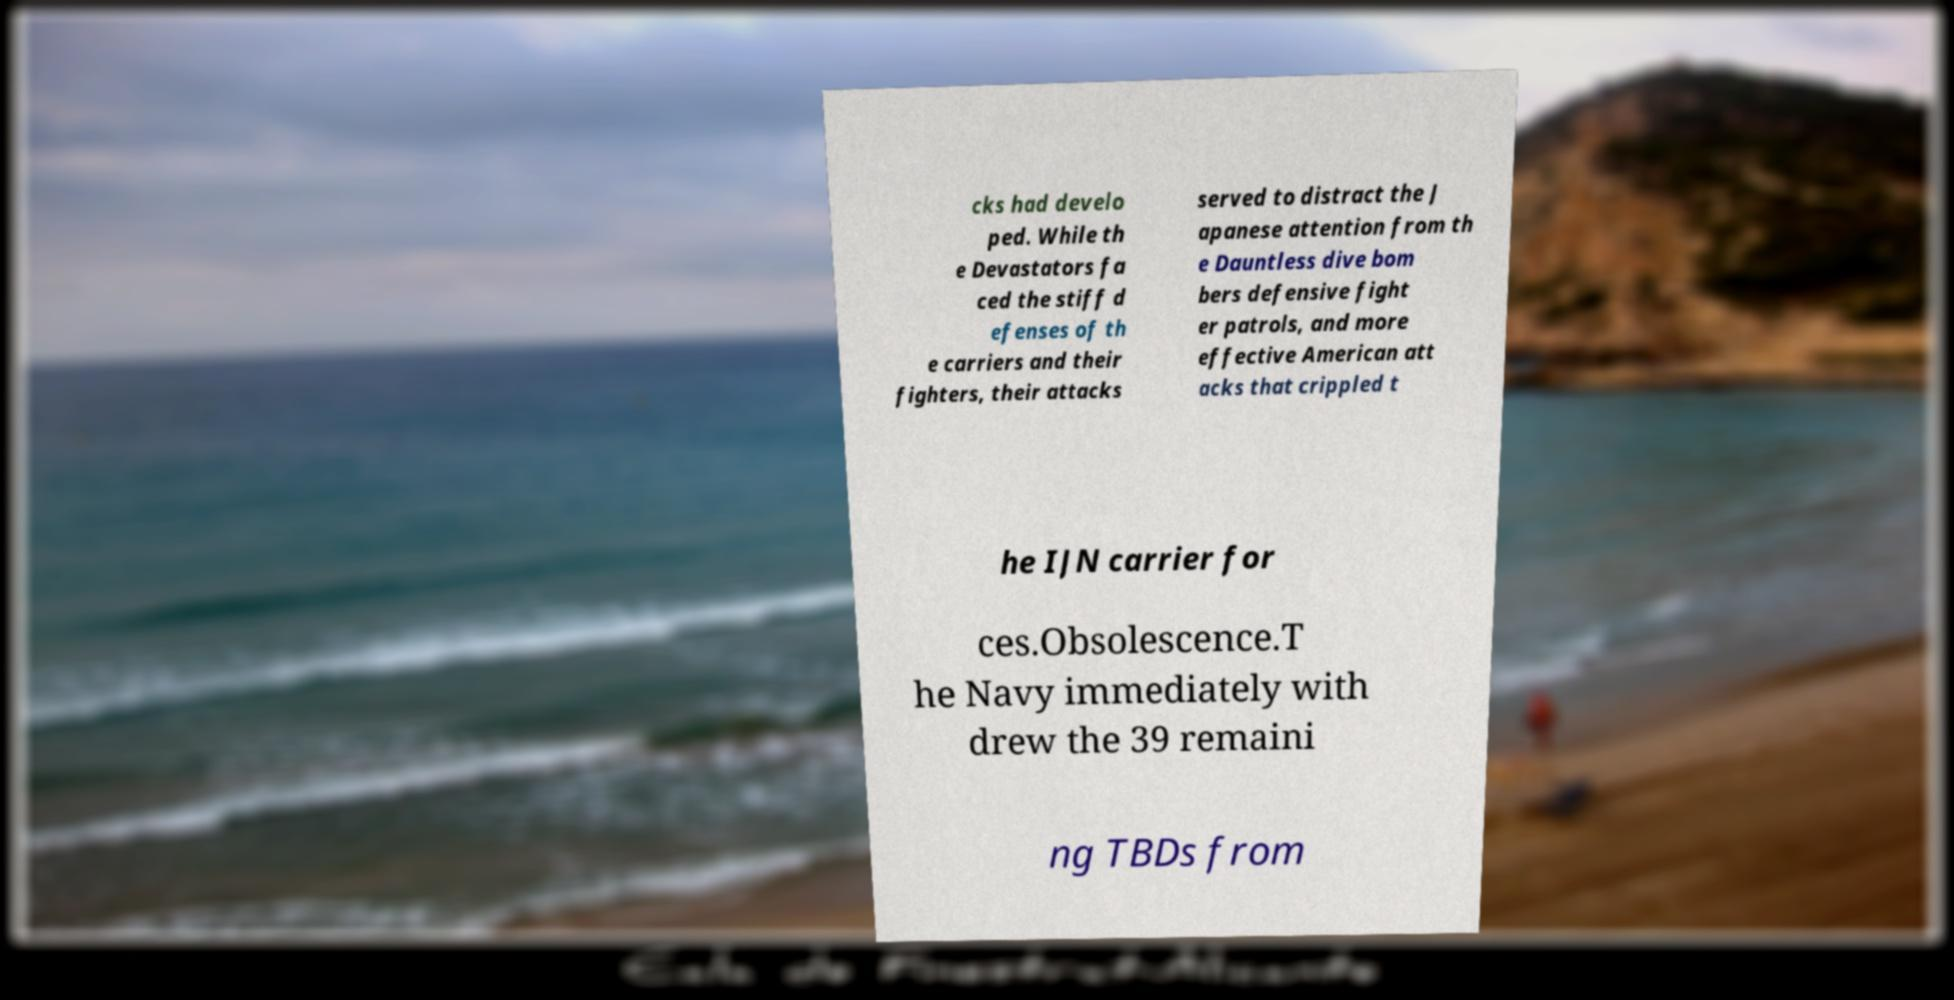I need the written content from this picture converted into text. Can you do that? cks had develo ped. While th e Devastators fa ced the stiff d efenses of th e carriers and their fighters, their attacks served to distract the J apanese attention from th e Dauntless dive bom bers defensive fight er patrols, and more effective American att acks that crippled t he IJN carrier for ces.Obsolescence.T he Navy immediately with drew the 39 remaini ng TBDs from 